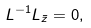Convert formula to latex. <formula><loc_0><loc_0><loc_500><loc_500>L ^ { - 1 } L _ { \bar { z } } = 0 ,</formula> 